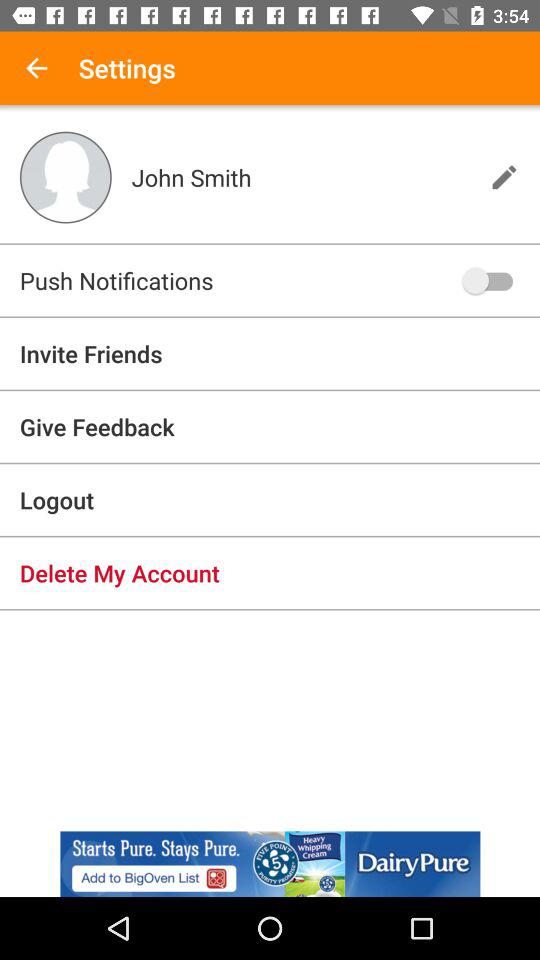How many friends have been invited?
When the provided information is insufficient, respond with <no answer>. <no answer> 